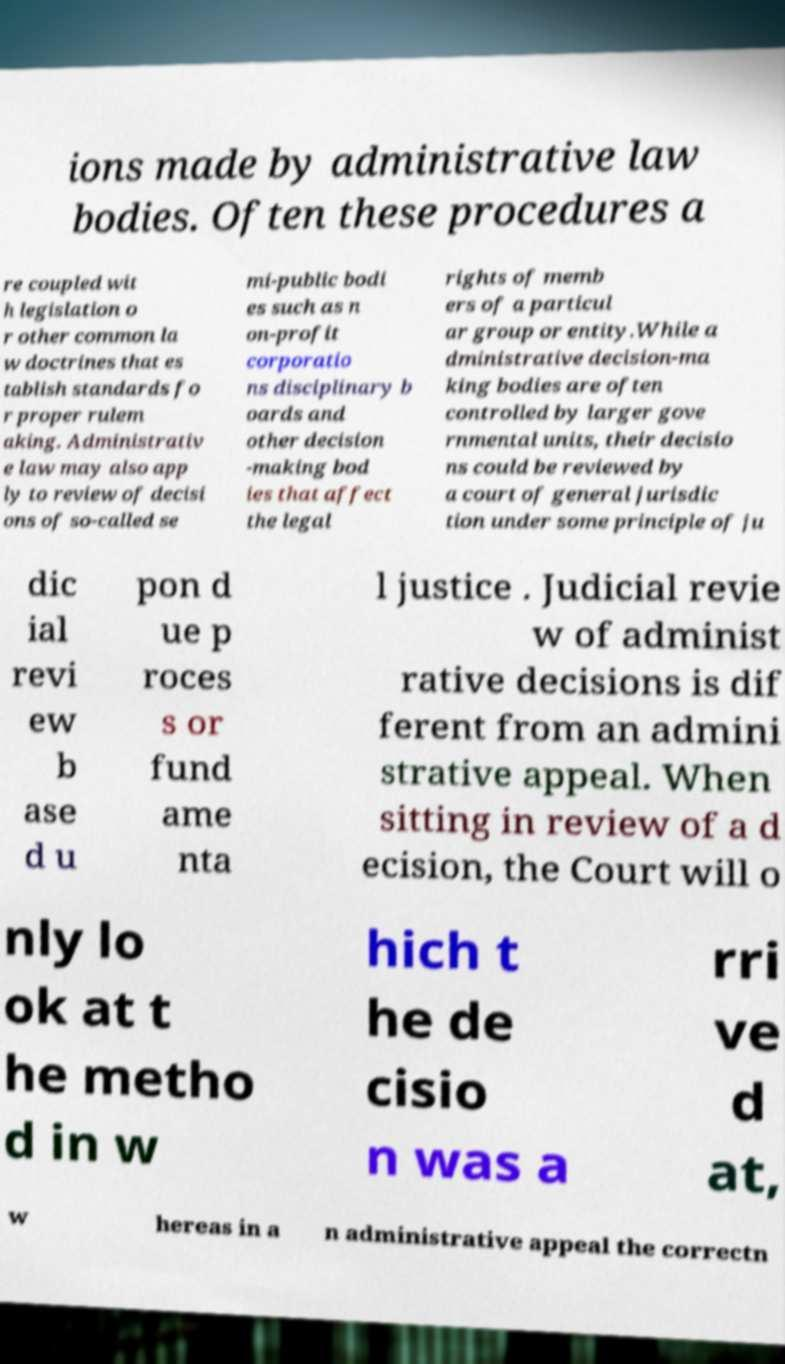What messages or text are displayed in this image? I need them in a readable, typed format. ions made by administrative law bodies. Often these procedures a re coupled wit h legislation o r other common la w doctrines that es tablish standards fo r proper rulem aking. Administrativ e law may also app ly to review of decisi ons of so-called se mi-public bodi es such as n on-profit corporatio ns disciplinary b oards and other decision -making bod ies that affect the legal rights of memb ers of a particul ar group or entity.While a dministrative decision-ma king bodies are often controlled by larger gove rnmental units, their decisio ns could be reviewed by a court of general jurisdic tion under some principle of ju dic ial revi ew b ase d u pon d ue p roces s or fund ame nta l justice . Judicial revie w of administ rative decisions is dif ferent from an admini strative appeal. When sitting in review of a d ecision, the Court will o nly lo ok at t he metho d in w hich t he de cisio n was a rri ve d at, w hereas in a n administrative appeal the correctn 